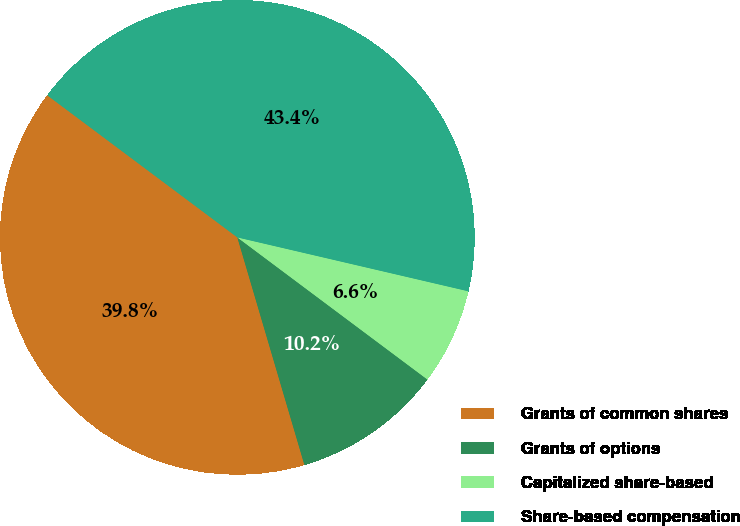Convert chart to OTSL. <chart><loc_0><loc_0><loc_500><loc_500><pie_chart><fcel>Grants of common shares<fcel>Grants of options<fcel>Capitalized share-based<fcel>Share-based compensation<nl><fcel>39.78%<fcel>10.22%<fcel>6.57%<fcel>43.43%<nl></chart> 